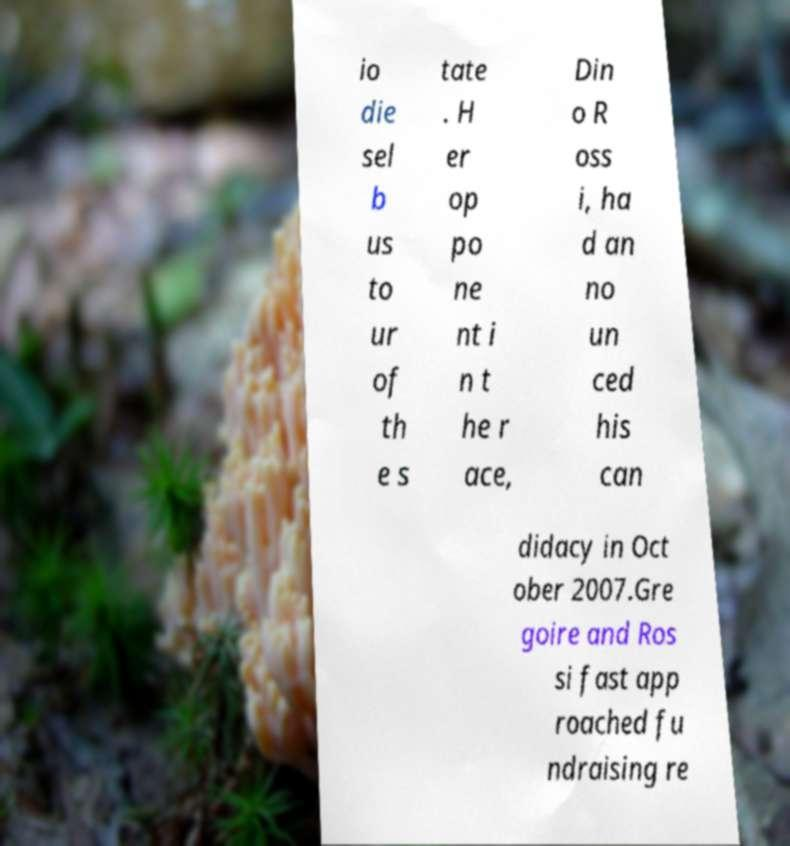Please identify and transcribe the text found in this image. io die sel b us to ur of th e s tate . H er op po ne nt i n t he r ace, Din o R oss i, ha d an no un ced his can didacy in Oct ober 2007.Gre goire and Ros si fast app roached fu ndraising re 